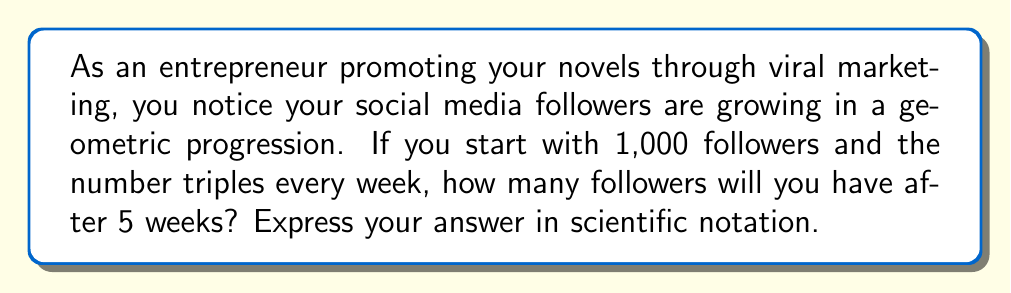Provide a solution to this math problem. Let's approach this step-by-step:

1) In a geometric progression, each term is a constant multiple of the previous term. Here, the constant is 3 (tripling each week).

2) We start with 1,000 followers and need to calculate after 5 weeks.

3) The formula for the nth term of a geometric progression is:
   
   $a_n = a_1 \cdot r^{n-1}$

   Where $a_n$ is the nth term, $a_1$ is the first term, r is the common ratio, and n is the position of the term.

4) In our case:
   $a_1 = 1,000$
   $r = 3$
   $n = 6$ (5 weeks of growth plus the initial week)

5) Plugging into the formula:

   $a_6 = 1,000 \cdot 3^{6-1}$
   $a_6 = 1,000 \cdot 3^5$

6) Calculate:
   $a_6 = 1,000 \cdot 243 = 243,000$

7) Convert to scientific notation:
   $243,000 = 2.43 \times 10^5$
Answer: $2.43 \times 10^5$ 